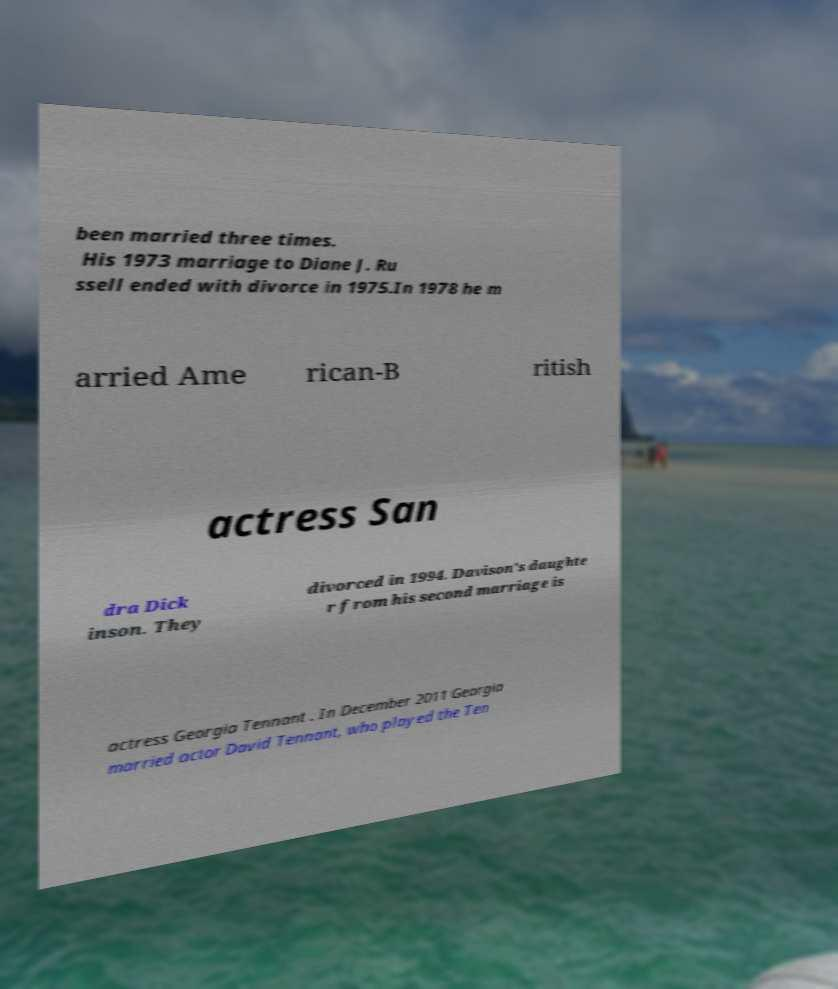Please identify and transcribe the text found in this image. been married three times. His 1973 marriage to Diane J. Ru ssell ended with divorce in 1975.In 1978 he m arried Ame rican-B ritish actress San dra Dick inson. They divorced in 1994. Davison's daughte r from his second marriage is actress Georgia Tennant . In December 2011 Georgia married actor David Tennant, who played the Ten 